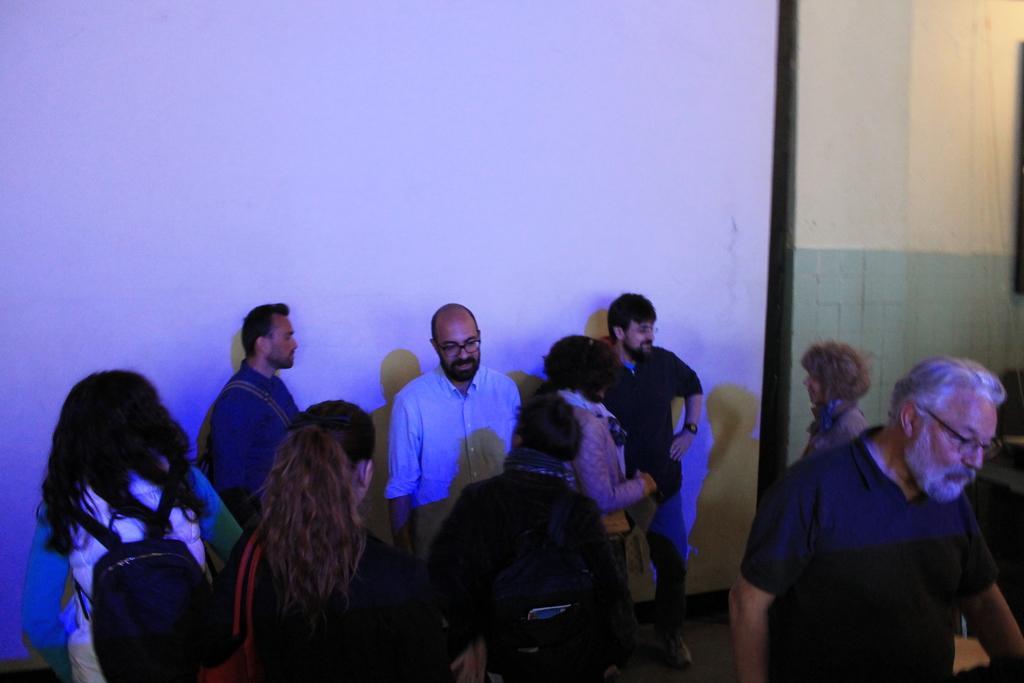Can you describe this image briefly? In this image we can see there are so many people standing in a room where some are wearing backpacks. 